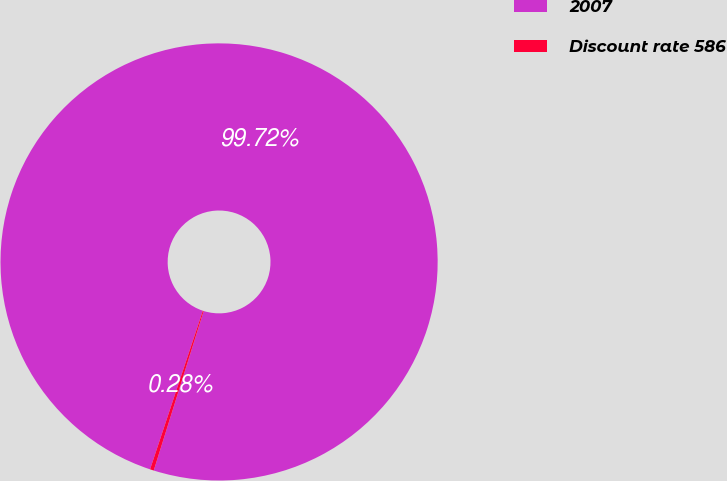Convert chart. <chart><loc_0><loc_0><loc_500><loc_500><pie_chart><fcel>2007<fcel>Discount rate 586<nl><fcel>99.72%<fcel>0.28%<nl></chart> 